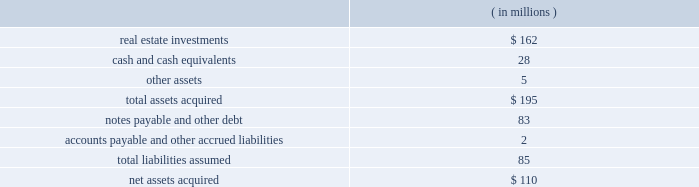Note 6 2014mergers and acquisitions eldertrust merger on february 5 , 2004 , the company consummated a merger transaction in an all cash transaction valued at $ 184 million ( the 201celdertrust transaction 201d ) .
The eldertrust transaction adds nine assisted living facilities , one independent living facility , five skilled nursing facilities , two med- ical office buildings and a financial office building ( the 201celdertrust properties 201d ) to the company 2019s portfolio.the eldertrust properties are leased by the company to various operators under leases providing for aggregated , annual cash base rent of approxi- mately $ 16.2 million , subject to escalation as provided in the leases.the leases have remaining terms primarily ranging from four to 11 years.at the closing of the eldertrust transaction , the company also acquired all of the limited partnership units in eldertrust operating limited partnership ( 201cetop 201d ) directly from their owners at $ 12.50 per unit , excluding 31455 class c units in etop ( which will remain outstanding ) .
Etop owns directly or indirectly all of the eldertrust properties .
The company funded the $ 101 million equity portion of the purchase price with cash on eldertrust 2019s balance sheet , a portion of the $ 85 million in proceeds from its december 2003 sale of ten facilities to kindred and draws on the company 2019s revolving credit facility ( the 201crevolving credit facility 201d ) under its second amended and restated security and guaranty agreement , dated as of april 17 , 2002 ( the 201c2002 credit agreement 201d ) .the company 2019s ownership of the eldertrust properties is subject to approximately $ 83 million of property level debt and other liabilities.at the close of the eldertrust transaction , eldertrust had approximately $ 33.5 million in unrestricted and restricted cash on hand .
The acquisition was accounted for under the purchase method .
The table summarizes the preliminary estimated fair values of the assets acquired and liabilities assumed at the date of acquisition .
Such estimates are subject to refinement as additional valuation information is received .
Operations from this merger will be reflected in the company 2019s consolidated financial state- ments for periods subsequent to the acquisition date of february 5 , 2004.the company is in the process of computing fair values , thus , the allocation of the purchase price is subject to refinement. .
Transaction with brookdale on january 29 , 2004 , the company entered into 14 definitive purchase agreements ( each , a 201cbrookdale purchase agreement 201d ) with certain affiliates of brookdale living communities , inc .
( 201cbrookdale 201d ) to purchase ( each such purchase , a 201cbrookdale acquisition 201d ) a total of 14 independent living or assisted living facilities ( each , a 201cbrookdale facility 201d ) for an aggregate purchase price of $ 115 million.affiliates of brookdale have agreed to lease and operate the brookdale facilities pursuant to one or more triple-net leases.all of the brookdale leases , which have an initial term of 15 years , will be guaranteed by brookdale and provide for aggregated annual base rent of approximately $ 10 million , escalating each year by the greater of ( i ) 1.5% ( 1.5 % ) or ( ii ) 75% ( 75 % ) of the consumer price index .
The company expects to fund the brookdale acquisitions by assuming an aggregate of approximately $ 41 million of non- recourse property level debt on certain of the brookdale facilities , with the balance to be paid from cash on hand and/or draws on the revolving credit facility.the property level debt encumbers seven of the brookdale facilities .
On january 29 , 2004 , the company completed the acquisitions of four brookdale facilities for an aggregate purchase price of $ 37 million.the company 2019s acquisition of the remaining ten brookdale facilities is expected to be completed shortly , subject to customary closing conditions .
However , the consummation of each such brookdale acquisition is not conditioned upon the consummation of any other such brookdale acquisition and there can be no assurance which , if any , of such remaining brookdale acquisitions will be consummated or when they will be consummated .
Transactions with trans healthcare , inc .
On november 4 , 2002 , the company , through its wholly owned subsidiary ventas realty , completed a $ 120.0 million transaction ( the 201cthi transaction 201d ) with trans healthcare , inc. , a privately owned long-term care and hospital company ( 201cthi 201d ) .the thi transaction was structured as a $ 53.0 million sale leaseback trans- action ( the 201cthi sale leaseback 201d ) and a $ 67.0 million loan ( the 201cthi loan 201d ) , comprised of a first mortgage loan ( the 201cthi senior loan 201d ) and a mezzanine loan ( the 201cthi mezzanine loan 201d ) .
Following a sale of the thi senior loan in december 2002 ( see below ) , the company 2019s investment in thi was $ 70.0 million .
As part of the thi sale leasebackventas realty purchased 5 properties and is leasing them back to thi under a 201ctriple-net 201d master lease ( the 201cthi master lease 201d ) .the properties subject to the sale leaseback are four skilled nursing facilities and one con- tinuing care retirement community.the thi master lease , which has an initial term of ten years , provides for annual base rent of $ 5.9 million.the thi master lease provides that if thi meets specified revenue parameters , annual base rent will escalate each year by the greater of ( i ) three percent or ( ii ) 50% ( 50 % ) of the consumer price index .
Ventas , inc .
Page 37 annual report 2003 .
What percentage of total assets acquired were real estate investments? 
Computations: (162 / 195)
Answer: 0.83077. Note 6 2014mergers and acquisitions eldertrust merger on february 5 , 2004 , the company consummated a merger transaction in an all cash transaction valued at $ 184 million ( the 201celdertrust transaction 201d ) .
The eldertrust transaction adds nine assisted living facilities , one independent living facility , five skilled nursing facilities , two med- ical office buildings and a financial office building ( the 201celdertrust properties 201d ) to the company 2019s portfolio.the eldertrust properties are leased by the company to various operators under leases providing for aggregated , annual cash base rent of approxi- mately $ 16.2 million , subject to escalation as provided in the leases.the leases have remaining terms primarily ranging from four to 11 years.at the closing of the eldertrust transaction , the company also acquired all of the limited partnership units in eldertrust operating limited partnership ( 201cetop 201d ) directly from their owners at $ 12.50 per unit , excluding 31455 class c units in etop ( which will remain outstanding ) .
Etop owns directly or indirectly all of the eldertrust properties .
The company funded the $ 101 million equity portion of the purchase price with cash on eldertrust 2019s balance sheet , a portion of the $ 85 million in proceeds from its december 2003 sale of ten facilities to kindred and draws on the company 2019s revolving credit facility ( the 201crevolving credit facility 201d ) under its second amended and restated security and guaranty agreement , dated as of april 17 , 2002 ( the 201c2002 credit agreement 201d ) .the company 2019s ownership of the eldertrust properties is subject to approximately $ 83 million of property level debt and other liabilities.at the close of the eldertrust transaction , eldertrust had approximately $ 33.5 million in unrestricted and restricted cash on hand .
The acquisition was accounted for under the purchase method .
The table summarizes the preliminary estimated fair values of the assets acquired and liabilities assumed at the date of acquisition .
Such estimates are subject to refinement as additional valuation information is received .
Operations from this merger will be reflected in the company 2019s consolidated financial state- ments for periods subsequent to the acquisition date of february 5 , 2004.the company is in the process of computing fair values , thus , the allocation of the purchase price is subject to refinement. .
Transaction with brookdale on january 29 , 2004 , the company entered into 14 definitive purchase agreements ( each , a 201cbrookdale purchase agreement 201d ) with certain affiliates of brookdale living communities , inc .
( 201cbrookdale 201d ) to purchase ( each such purchase , a 201cbrookdale acquisition 201d ) a total of 14 independent living or assisted living facilities ( each , a 201cbrookdale facility 201d ) for an aggregate purchase price of $ 115 million.affiliates of brookdale have agreed to lease and operate the brookdale facilities pursuant to one or more triple-net leases.all of the brookdale leases , which have an initial term of 15 years , will be guaranteed by brookdale and provide for aggregated annual base rent of approximately $ 10 million , escalating each year by the greater of ( i ) 1.5% ( 1.5 % ) or ( ii ) 75% ( 75 % ) of the consumer price index .
The company expects to fund the brookdale acquisitions by assuming an aggregate of approximately $ 41 million of non- recourse property level debt on certain of the brookdale facilities , with the balance to be paid from cash on hand and/or draws on the revolving credit facility.the property level debt encumbers seven of the brookdale facilities .
On january 29 , 2004 , the company completed the acquisitions of four brookdale facilities for an aggregate purchase price of $ 37 million.the company 2019s acquisition of the remaining ten brookdale facilities is expected to be completed shortly , subject to customary closing conditions .
However , the consummation of each such brookdale acquisition is not conditioned upon the consummation of any other such brookdale acquisition and there can be no assurance which , if any , of such remaining brookdale acquisitions will be consummated or when they will be consummated .
Transactions with trans healthcare , inc .
On november 4 , 2002 , the company , through its wholly owned subsidiary ventas realty , completed a $ 120.0 million transaction ( the 201cthi transaction 201d ) with trans healthcare , inc. , a privately owned long-term care and hospital company ( 201cthi 201d ) .the thi transaction was structured as a $ 53.0 million sale leaseback trans- action ( the 201cthi sale leaseback 201d ) and a $ 67.0 million loan ( the 201cthi loan 201d ) , comprised of a first mortgage loan ( the 201cthi senior loan 201d ) and a mezzanine loan ( the 201cthi mezzanine loan 201d ) .
Following a sale of the thi senior loan in december 2002 ( see below ) , the company 2019s investment in thi was $ 70.0 million .
As part of the thi sale leasebackventas realty purchased 5 properties and is leasing them back to thi under a 201ctriple-net 201d master lease ( the 201cthi master lease 201d ) .the properties subject to the sale leaseback are four skilled nursing facilities and one con- tinuing care retirement community.the thi master lease , which has an initial term of ten years , provides for annual base rent of $ 5.9 million.the thi master lease provides that if thi meets specified revenue parameters , annual base rent will escalate each year by the greater of ( i ) three percent or ( ii ) 50% ( 50 % ) of the consumer price index .
Ventas , inc .
Page 37 annual report 2003 .
What percentage of total assets acquired were real estate investments? 
Computations: (162 / 195)
Answer: 0.83077. 